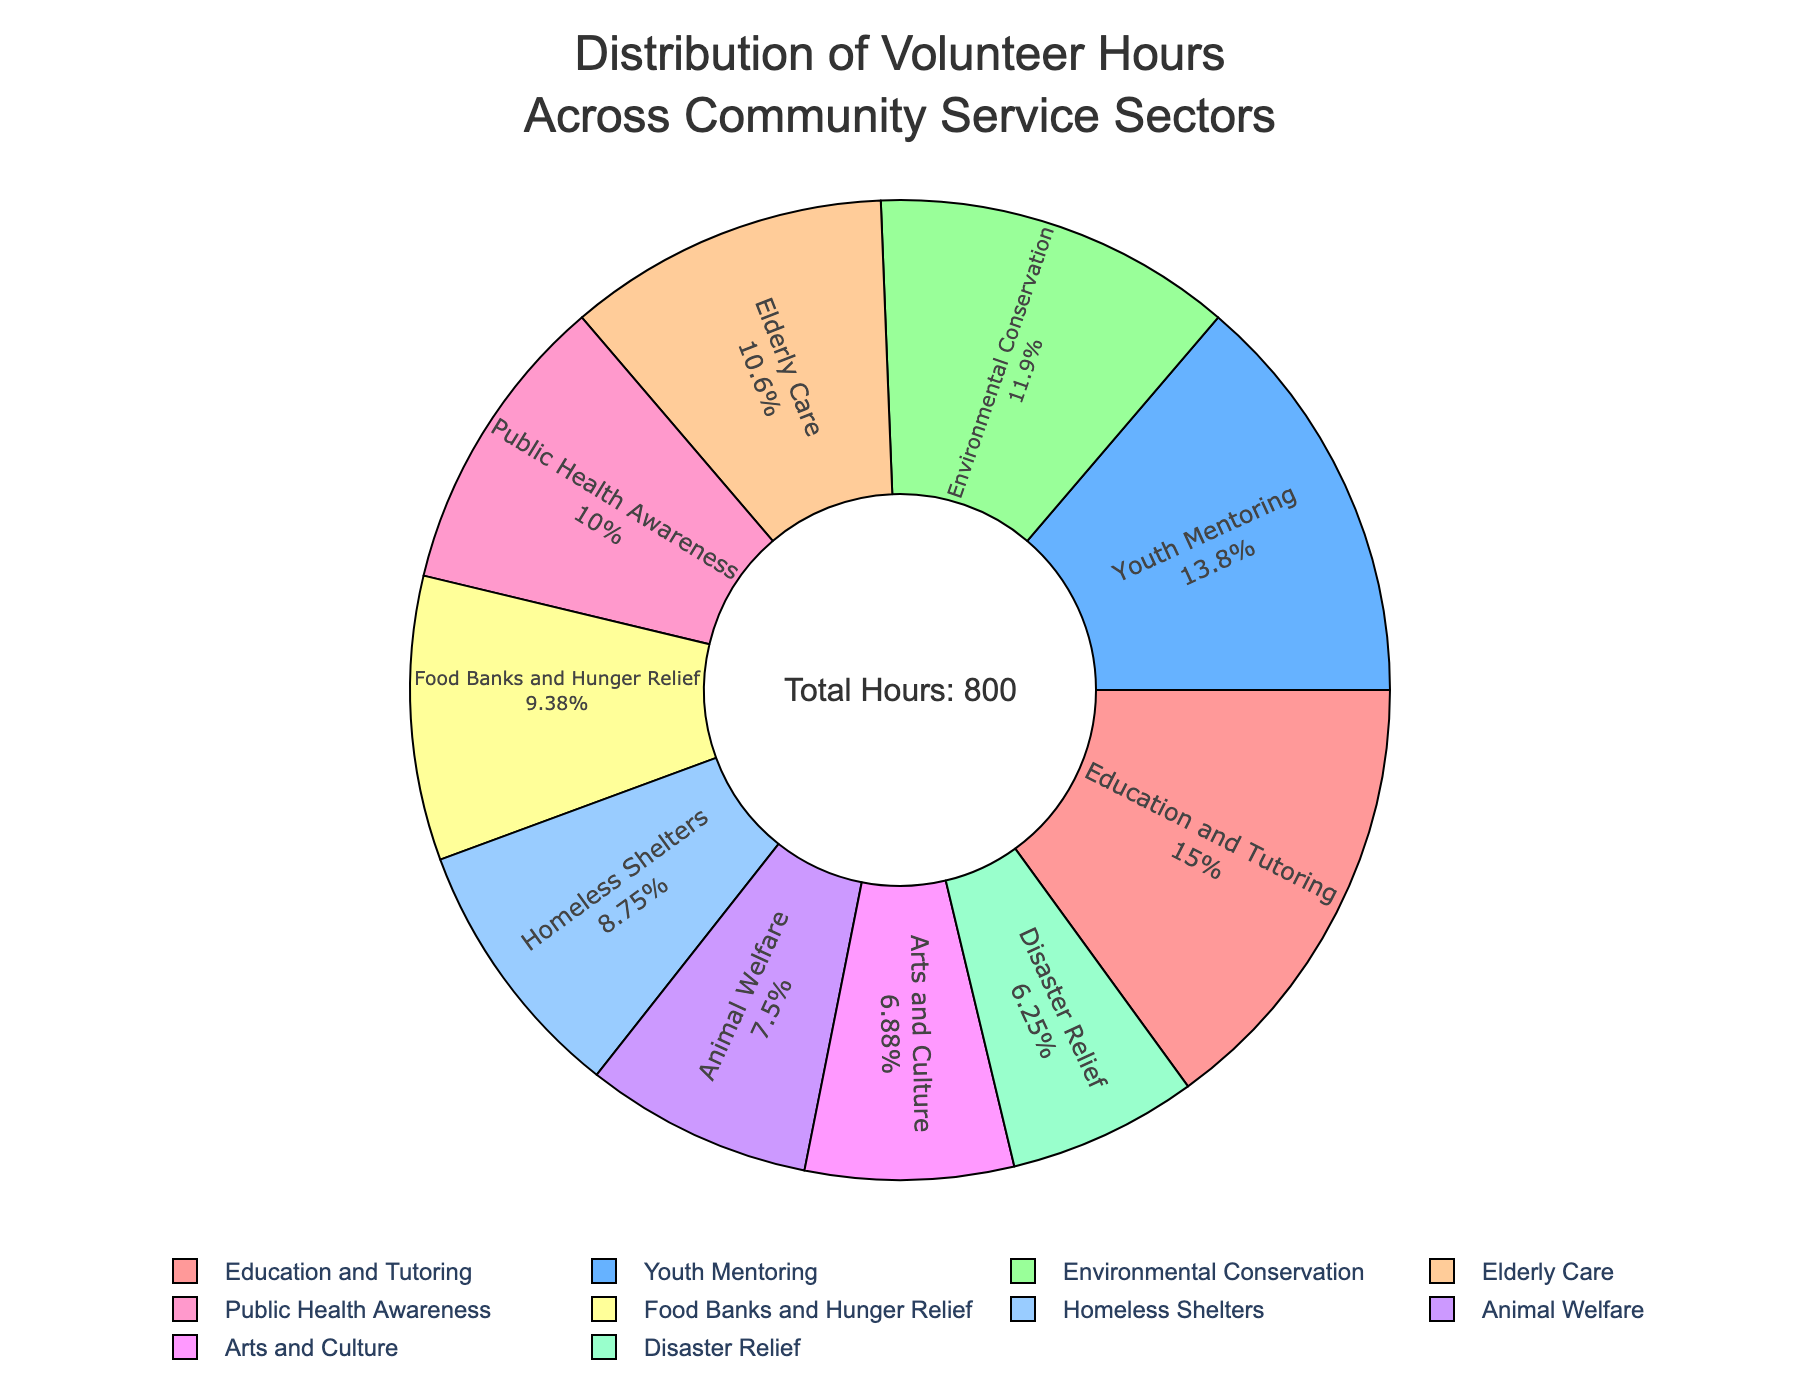Which sector has the highest volunteer hours? Look at the slices of the pie chart and identify the largest one. The sector with the biggest slice represents the highest volunteer hours. The Education and Tutoring sector has the largest slice.
Answer: Education and Tutoring Which sector has the smallest volunteer hours? Look at the slices of the pie chart and identify the smallest one. The sector with the smallest slice represents the fewest volunteer hours. The smallest slice corresponds to the Disaster Relief sector.
Answer: Disaster Relief How do the volunteer hours for Elderly Care compare to those for Youth Mentoring? The Elderly Care slice is smaller than the Youth Mentoring slice. Elderly Care has 85 hours, while Youth Mentoring has 110 hours, indicating that Youth Mentoring has more hours.
Answer: Youth Mentoring has more hours What is the total percentage of volunteer hours for both Environmental Conservation and Public Health Awareness combined? Look at the slices of the pie chart for both sectors. Environmental Conservation is 95 hours, and Public Health Awareness is 80 hours. Sum these hours to get (95 + 80 = 175). Then, calculate the percentage (175 / 800 = 0.21875) and multiply it by 100 to get approximately 21.88%.
Answer: 21.88% Which sectors have volunteer hours that are close to 100? Identify the slices close to 100 hours. Both Education and Tutoring (120 hours) and Youth Mentoring (110 hours) are around 100 hours.
Answer: Education and Tutoring, Youth Mentoring If we combine the hours from Food Banks and Hunger Relief, Animal Welfare, and Homeless Shelters, what percentage of the total volunteer hours do these sectors represent? Add hours for Food Banks and Hunger Relief (75), Animal Welfare (60), and Homeless Shelters (70). Sum these hours (75 + 60 + 70 = 205). Calculate the percentage: (205 / 800 = 0.25625) and multiply by 100 to get approximately 25.63%.
Answer: 25.63% Which sector's slice is shown in green, and what are its volunteer hours? Look at the green slice in the pie chart. It represents Environmental Conservation. The chart indicates it has 95 hours.
Answer: Environmental Conservation, 95 hours What is the percentage difference between the volunteer hours of Arts and Culture and Disaster Relief? Calculate the hours difference: Arts and Culture (55), Disaster Relief (50). The difference is (55 - 50 = 5 hours). Calculate the percentage: (5 / 800) * 100 = 0.625%.
Answer: 0.625% How do the volunteer hours of Education and Tutoring and Youth Mentoring together compare to the total volunteer hours? Add hours for Education and Tutoring (120) and Youth Mentoring (110). Total these hours (120 + 110 = 230). Calculate the percentage (230 / 800 = 0.2875) and multiply by 100 to get 28.75%.
Answer: 28.75% 